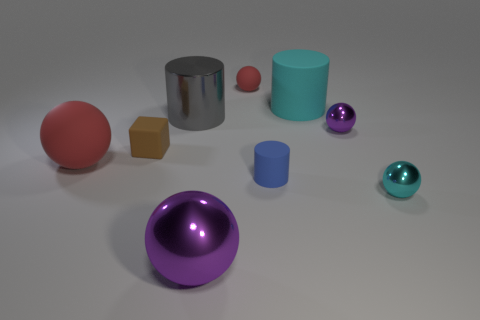What number of rubber things are blue things or large blue spheres?
Provide a short and direct response. 1. The rubber sphere that is the same size as the gray cylinder is what color?
Give a very brief answer. Red. How many big objects are the same shape as the tiny red matte thing?
Offer a terse response. 2. What number of blocks are either red things or tiny purple shiny objects?
Your response must be concise. 0. Does the small rubber thing on the left side of the small red rubber sphere have the same shape as the large thing that is left of the small rubber block?
Offer a very short reply. No. What is the brown thing made of?
Give a very brief answer. Rubber. What is the shape of the small matte object that is the same color as the large rubber ball?
Your answer should be very brief. Sphere. What number of cyan cylinders are the same size as the matte cube?
Give a very brief answer. 0. What number of things are either red matte objects that are on the right side of the gray thing or small matte objects behind the small purple metallic ball?
Provide a short and direct response. 1. Are the purple thing that is behind the cyan metallic sphere and the tiny thing that is behind the gray cylinder made of the same material?
Offer a terse response. No. 